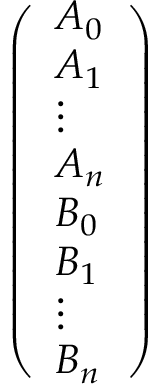Convert formula to latex. <formula><loc_0><loc_0><loc_500><loc_500>\begin{array} { r } { \left ( \begin{array} { l } { A _ { 0 } } \\ { A _ { 1 } } \\ { \vdots } \\ { A _ { n } } \\ { B _ { 0 } } \\ { B _ { 1 } } \\ { \vdots } \\ { B _ { n } } \end{array} \right ) } \end{array}</formula> 